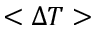<formula> <loc_0><loc_0><loc_500><loc_500>< \Delta T ></formula> 